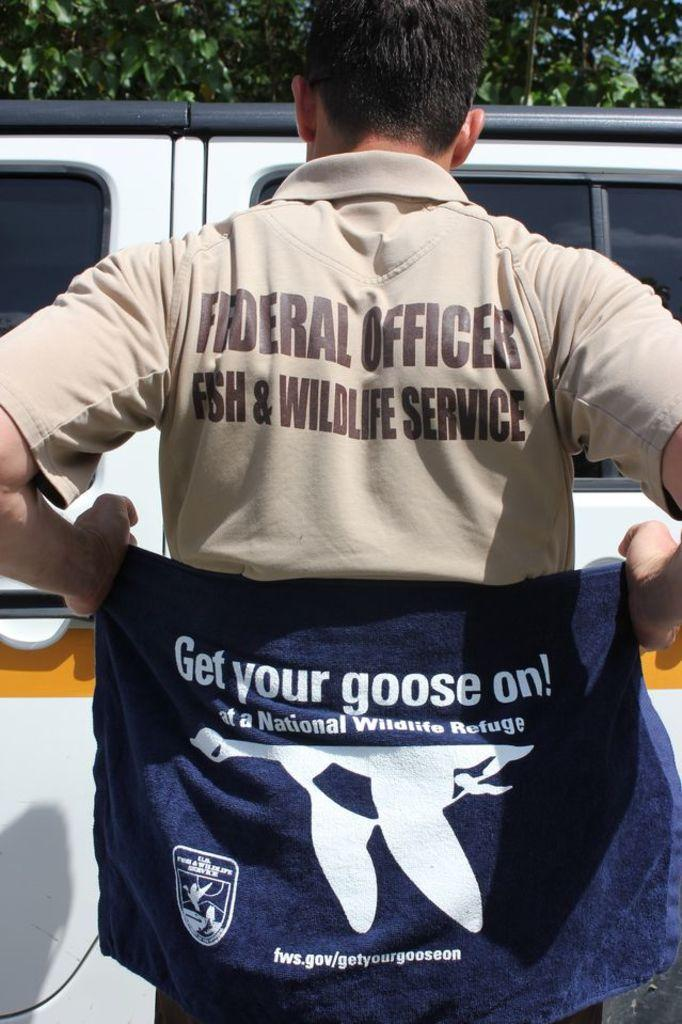<image>
Offer a succinct explanation of the picture presented. The man shown is holding a top saying get your goose on. 